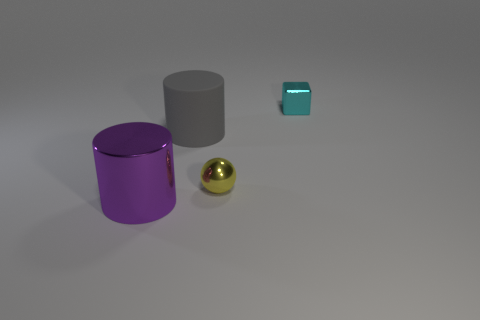Add 2 big cyan metal cubes. How many objects exist? 6 Subtract all cubes. How many objects are left? 3 Subtract 1 cubes. How many cubes are left? 0 Subtract all tiny balls. Subtract all tiny rubber spheres. How many objects are left? 3 Add 2 large purple objects. How many large purple objects are left? 3 Add 1 large purple cylinders. How many large purple cylinders exist? 2 Subtract 0 yellow cylinders. How many objects are left? 4 Subtract all red blocks. Subtract all green cylinders. How many blocks are left? 1 Subtract all gray cubes. How many red cylinders are left? 0 